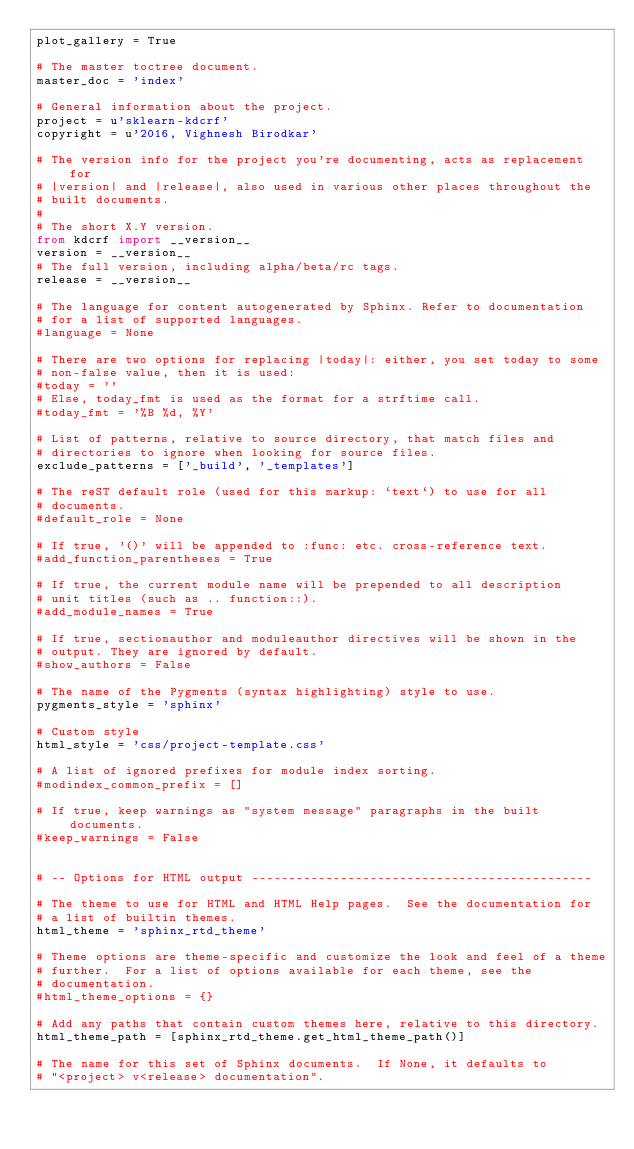Convert code to text. <code><loc_0><loc_0><loc_500><loc_500><_Python_>plot_gallery = True

# The master toctree document.
master_doc = 'index'

# General information about the project.
project = u'sklearn-kdcrf'
copyright = u'2016, Vighnesh Birodkar'

# The version info for the project you're documenting, acts as replacement for
# |version| and |release|, also used in various other places throughout the
# built documents.
#
# The short X.Y version.
from kdcrf import __version__
version = __version__
# The full version, including alpha/beta/rc tags.
release = __version__

# The language for content autogenerated by Sphinx. Refer to documentation
# for a list of supported languages.
#language = None

# There are two options for replacing |today|: either, you set today to some
# non-false value, then it is used:
#today = ''
# Else, today_fmt is used as the format for a strftime call.
#today_fmt = '%B %d, %Y'

# List of patterns, relative to source directory, that match files and
# directories to ignore when looking for source files.
exclude_patterns = ['_build', '_templates']

# The reST default role (used for this markup: `text`) to use for all
# documents.
#default_role = None

# If true, '()' will be appended to :func: etc. cross-reference text.
#add_function_parentheses = True

# If true, the current module name will be prepended to all description
# unit titles (such as .. function::).
#add_module_names = True

# If true, sectionauthor and moduleauthor directives will be shown in the
# output. They are ignored by default.
#show_authors = False

# The name of the Pygments (syntax highlighting) style to use.
pygments_style = 'sphinx'

# Custom style
html_style = 'css/project-template.css'

# A list of ignored prefixes for module index sorting.
#modindex_common_prefix = []

# If true, keep warnings as "system message" paragraphs in the built documents.
#keep_warnings = False


# -- Options for HTML output ----------------------------------------------

# The theme to use for HTML and HTML Help pages.  See the documentation for
# a list of builtin themes.
html_theme = 'sphinx_rtd_theme'

# Theme options are theme-specific and customize the look and feel of a theme
# further.  For a list of options available for each theme, see the
# documentation.
#html_theme_options = {}

# Add any paths that contain custom themes here, relative to this directory.
html_theme_path = [sphinx_rtd_theme.get_html_theme_path()]

# The name for this set of Sphinx documents.  If None, it defaults to
# "<project> v<release> documentation".</code> 